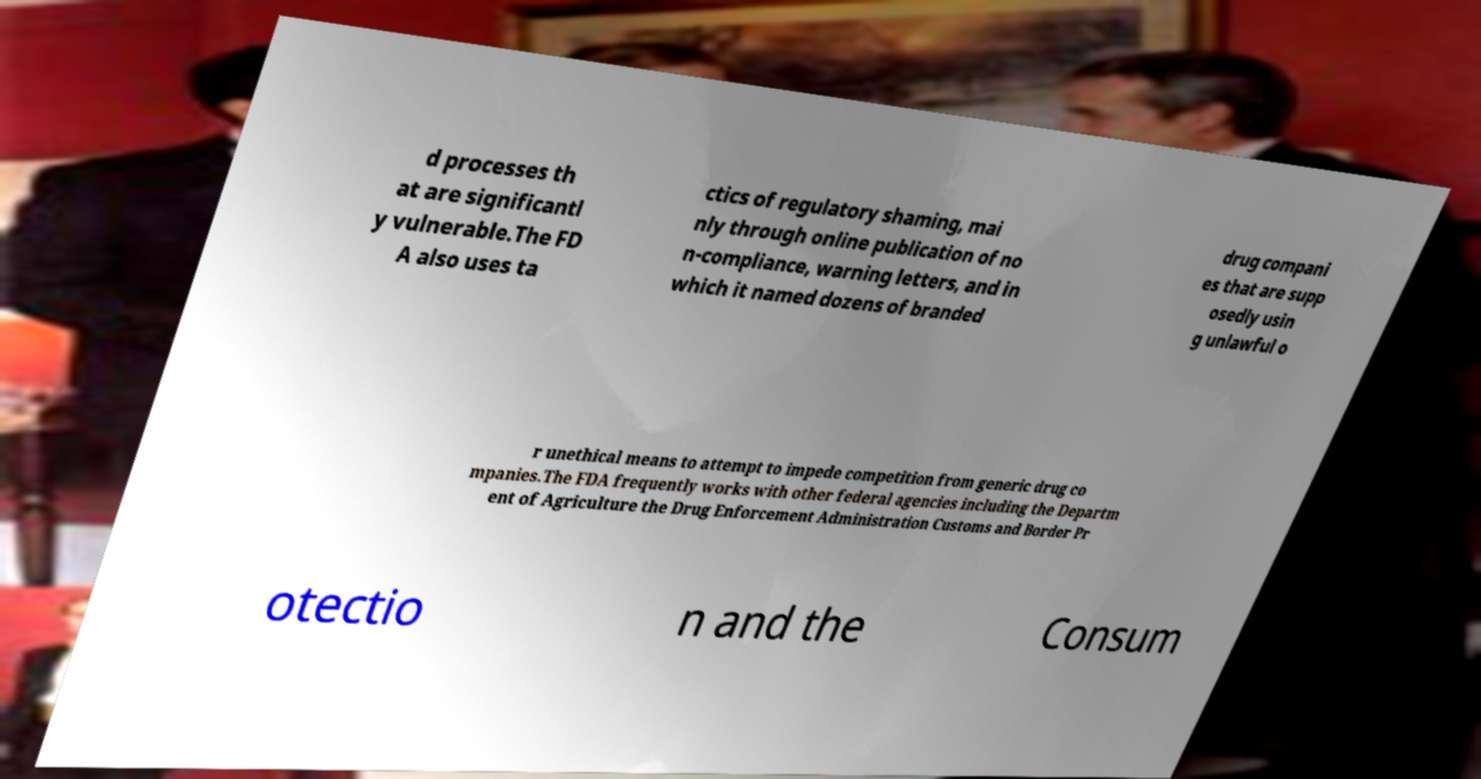What messages or text are displayed in this image? I need them in a readable, typed format. d processes th at are significantl y vulnerable.The FD A also uses ta ctics of regulatory shaming, mai nly through online publication of no n-compliance, warning letters, and in which it named dozens of branded drug compani es that are supp osedly usin g unlawful o r unethical means to attempt to impede competition from generic drug co mpanies.The FDA frequently works with other federal agencies including the Departm ent of Agriculture the Drug Enforcement Administration Customs and Border Pr otectio n and the Consum 